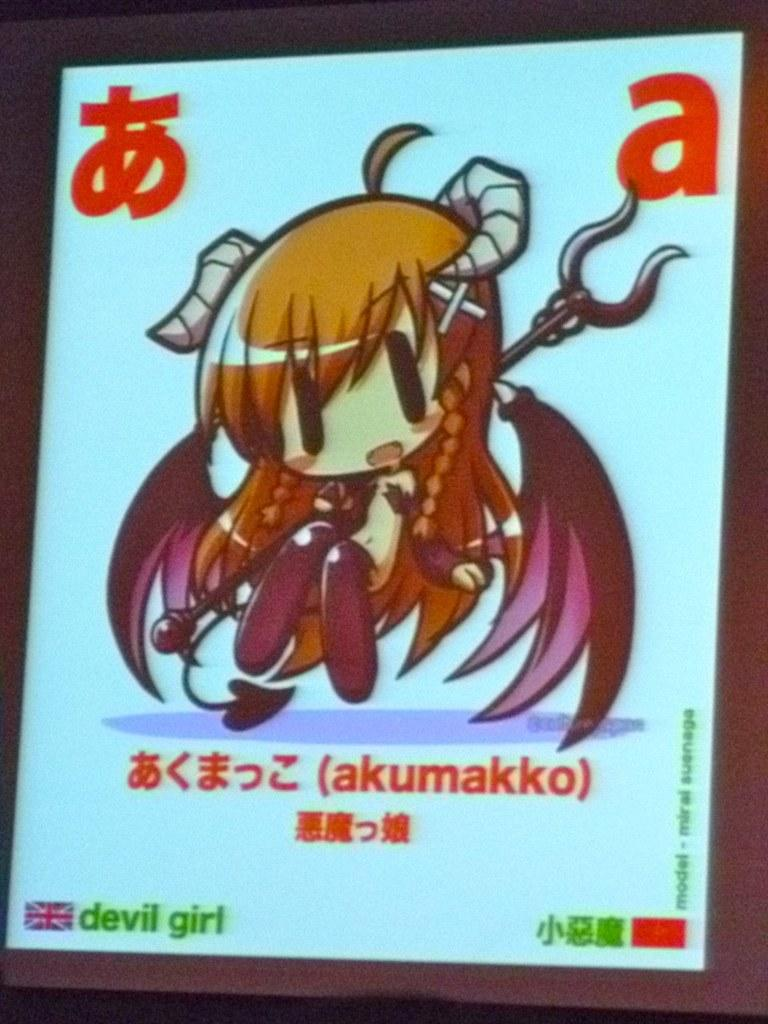<image>
Create a compact narrative representing the image presented. The image of an animated little girl with horns called devil girl. 